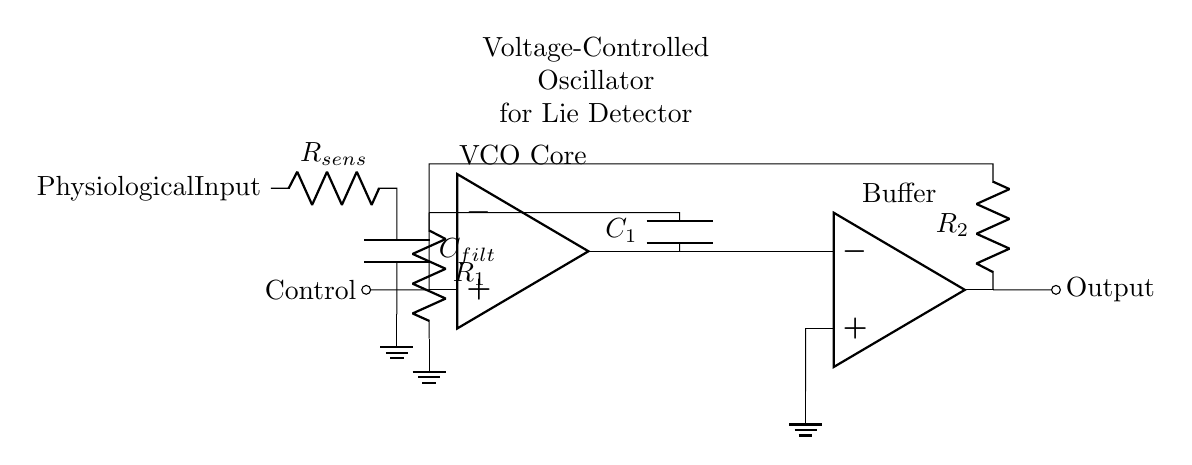What is the main component represented in the circuit? The main component is an operational amplifier, which is depicted at the center of the diagram and labeled as the VCO core.
Answer: Operational amplifier What controls the frequency of the oscillator? The control input, labeled as "Control," influences the behavior of the operational amplifier, thereby determining the frequency of oscillation.
Answer: Control How many resistors are present in the circuit? There are two resistors shown in the circuit, one labeled R1 connected to the op-amp and the other labeled R2 in the feedback loop.
Answer: Two What is the purpose of the capacitor labeled C1? Capacitor C1 functions as part of the feedback mechanism in the voltage-controlled oscillator, helping to set the oscillation frequency along with the resistors.
Answer: Feedback Which component is used to filter the physiological input? The component labeled C_filt with its connection to R_sens is responsible for filtering the physiological input before it reaches the VCO.
Answer: Capacitor How does the output buffer function in the circuit? The output buffer, which is another operational amplifier, serves to isolate the VCO output from the load, preventing the output from affecting the oscillator's performance.
Answer: Isolation What is the relationship between the physiological input and the control of the oscillator? The physiological input, after passing through the resistor R_sens and capacitor C_filt, modulates the control voltage, impacting the oscillator's frequency based on physiological responses.
Answer: Modulation 